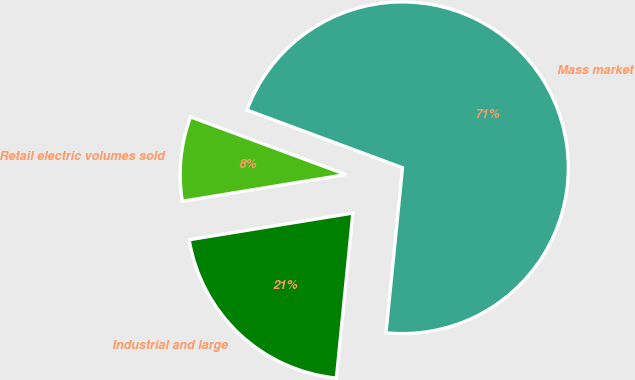Convert chart. <chart><loc_0><loc_0><loc_500><loc_500><pie_chart><fcel>Retail electric volumes sold<fcel>Industrial and large<fcel>Mass market<nl><fcel>8.23%<fcel>20.84%<fcel>70.93%<nl></chart> 